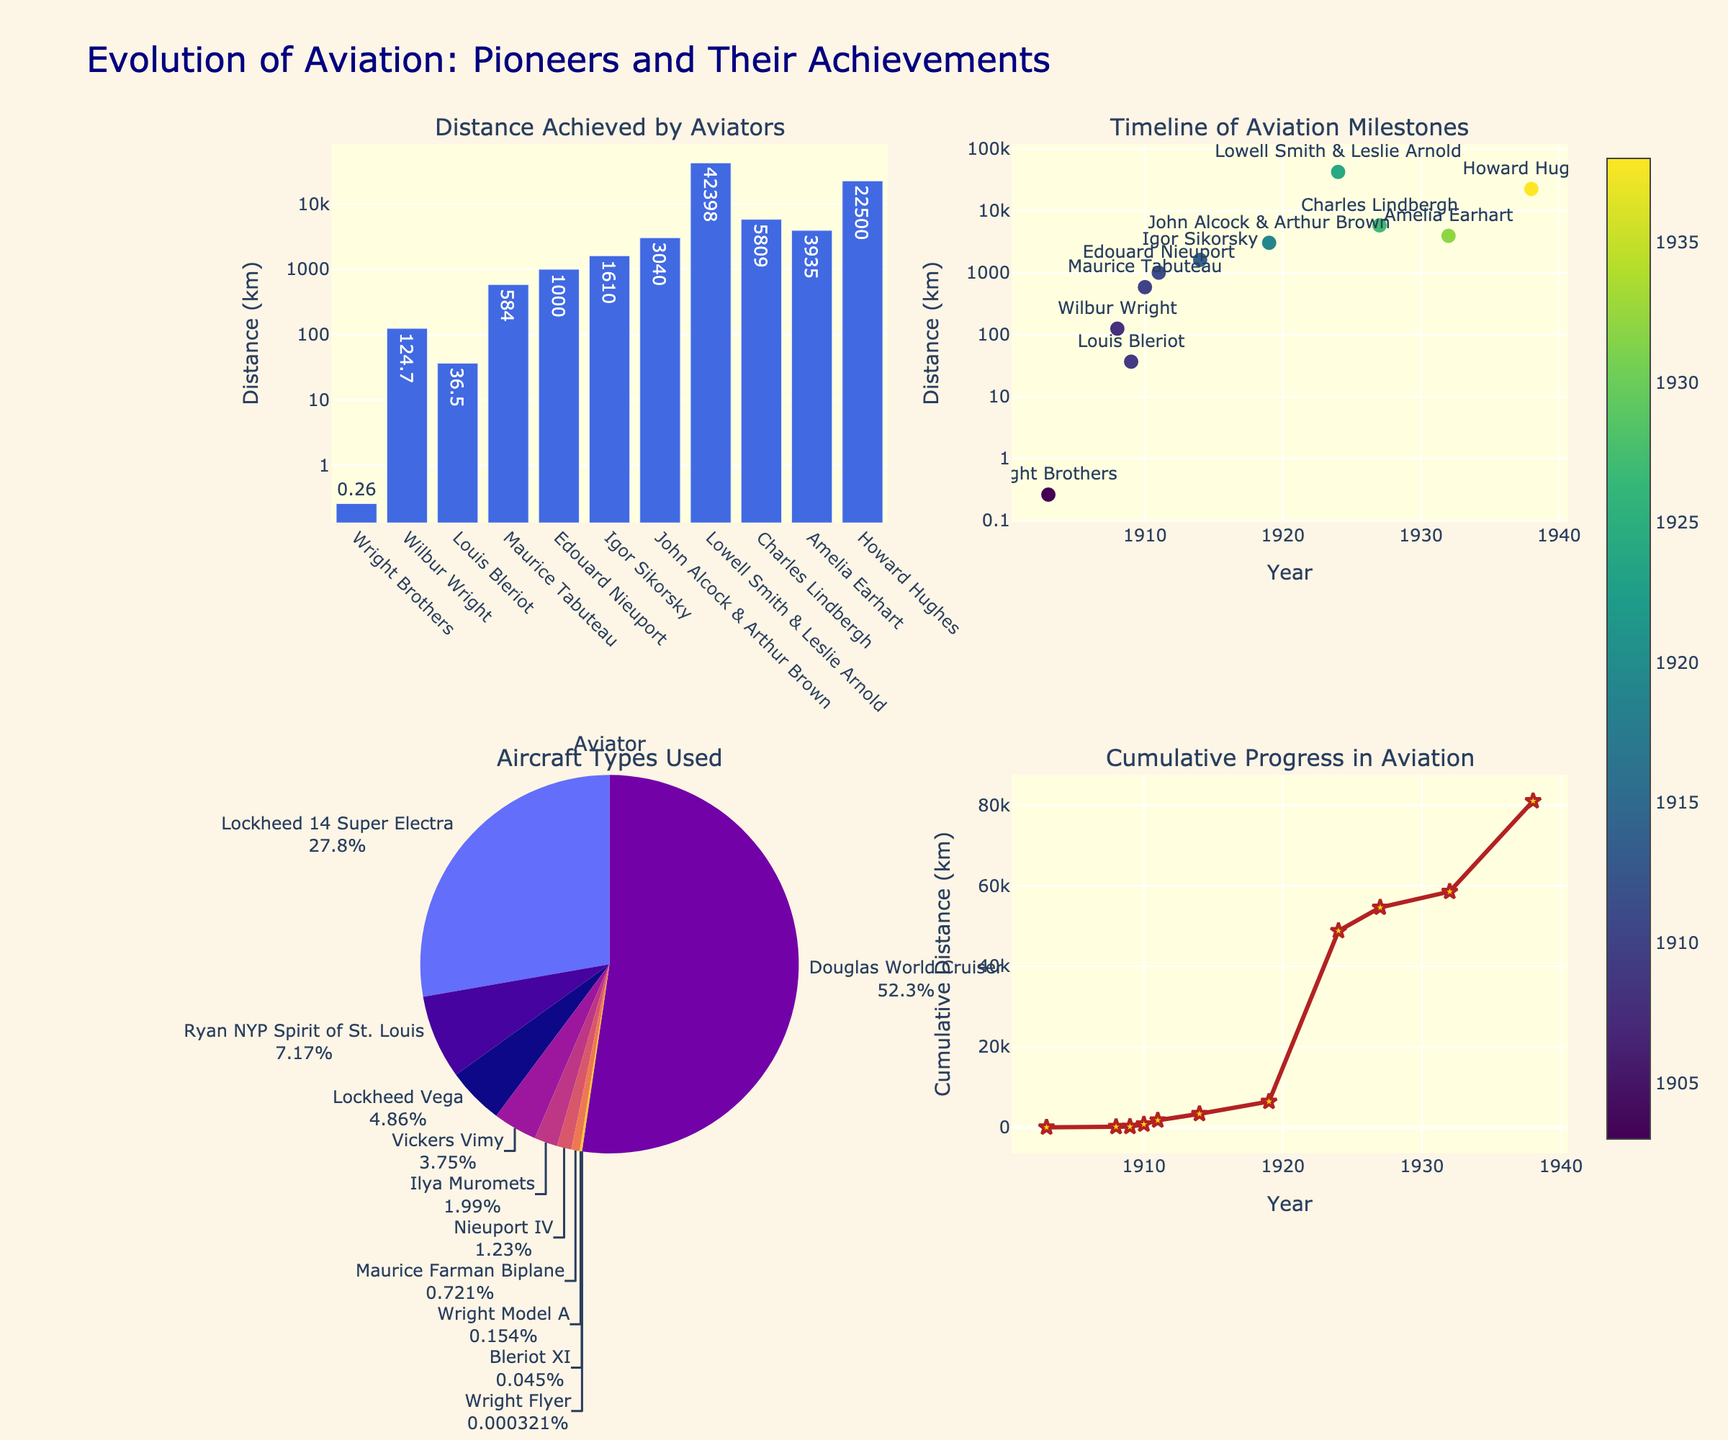What is the title of the figure? The title is placed at the top of the figure and states what the whole visual represents. In this case, you can see the title "Evolution of Aviation: Pioneers and Their Achievements".
Answer: Evolution of Aviation: Pioneers and Their Achievements Which aviator achieved the longest flight distance according to the bar chart in the top left subplot? The bar chart in the top left subplot shows distances with each aviator's name. The highest bar represents Lowell Smith & Leslie Arnold.
Answer: Lowell Smith & Leslie Arnold In the timeline scatter plot (top right), which aviator marked the earliest significant milestone in terms of flight distance? The scatter plot in the top right subplot maps years to flight distances with the aviator names shown. The earliest year (1903) indicates the Wright Brothers.
Answer: Wright Brothers What are the aircraft types mentioned in the pie chart (bottom left)? The pie chart (bottom left) divides the section into aircraft types, each labeled. The aircraft types listed are Wright Flyer, Wright Model A, Bleriot XI, Maurice Farman Biplane, Nieuport IV, Ilya Muromets, Vickers Vimy, Douglas World Cruiser, Ryan NYP Spirit of St. Louis, Lockheed Vega, and Lockheed 14 Super Electra.
Answer: Wright Flyer, Wright Model A, Bleriot XI, Maurice Farman Biplane, Nieuport IV, Ilya Muromets, Vickers Vimy, Douglas World Cruiser, Ryan NYP Spirit of St. Louis, Lockheed Vega, Lockheed 14 Super Electra Which aviator's achievement had the most significant share in terms of distance covered, according to the pie chart? Each section of the pie chart represents a portion of distance achieved by the aircraft types. By inspecting the pie chart, the Douglas World Cruiser (flown by Lowell Smith & Leslie Arnold) has the largest share.
Answer: Douglas World Cruiser In the line chart (bottom right), during which decade did the cumulative distance see the most significant increase? The line chart in the bottom right subplot traces the cumulative distance over time. The sharpest rise in the graph occurs between the 1920s and the 1930s.
Answer: 1920s-1930s What is the color scheme used for the scatter plot, and what does it represent? The scatter plot uses a color scheme ranging from yellow to purple. The colors represent the different years of the recorded flight distances, with a color scale bar displayed on the right.
Answer: Color scale representing years Looking at the bar chart and scatter plot, which aviator achieved the highest distance in the 1920s? The bar chart and scatter plot both show aviator distances and the years. In the 1920s, the highest distance was achieved by Lowell Smith & Leslie Arnold.
Answer: Lowell Smith & Leslie Arnold 